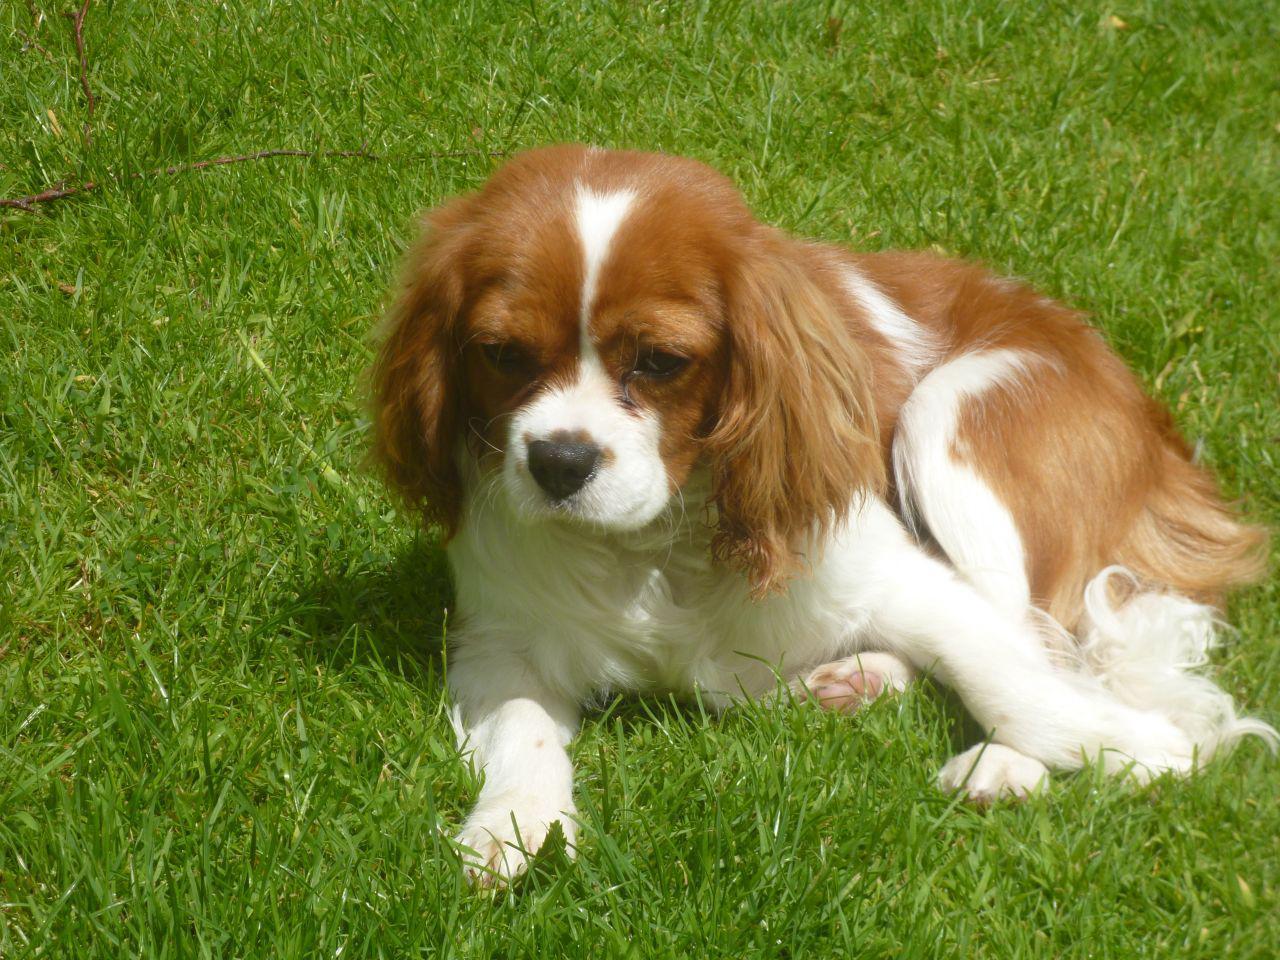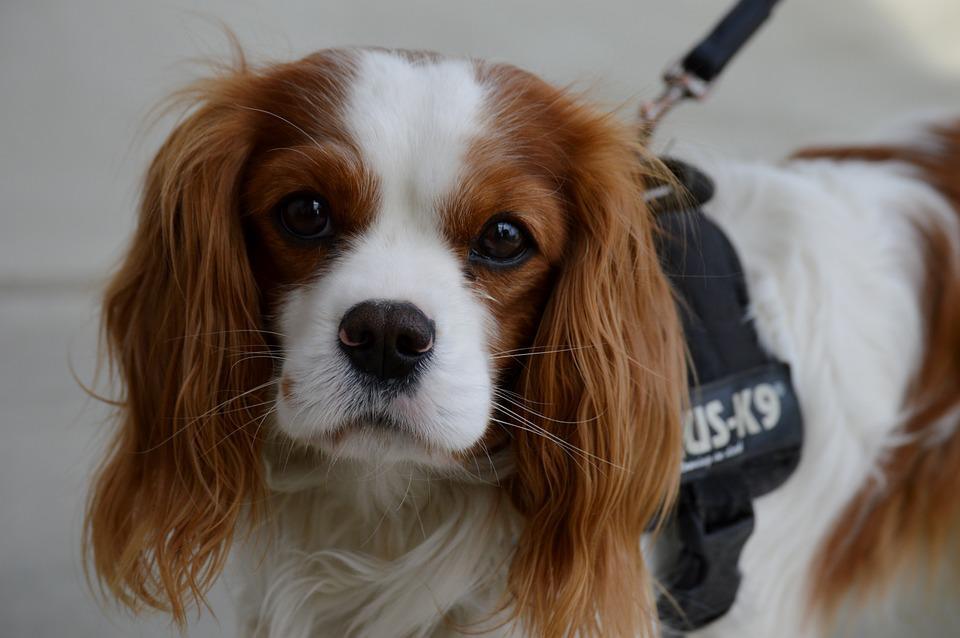The first image is the image on the left, the second image is the image on the right. Analyze the images presented: Is the assertion "There are only two puppies and neither has bows in its hair." valid? Answer yes or no. Yes. The first image is the image on the left, the second image is the image on the right. Evaluate the accuracy of this statement regarding the images: "the animal in the image on the left is lying down". Is it true? Answer yes or no. Yes. 